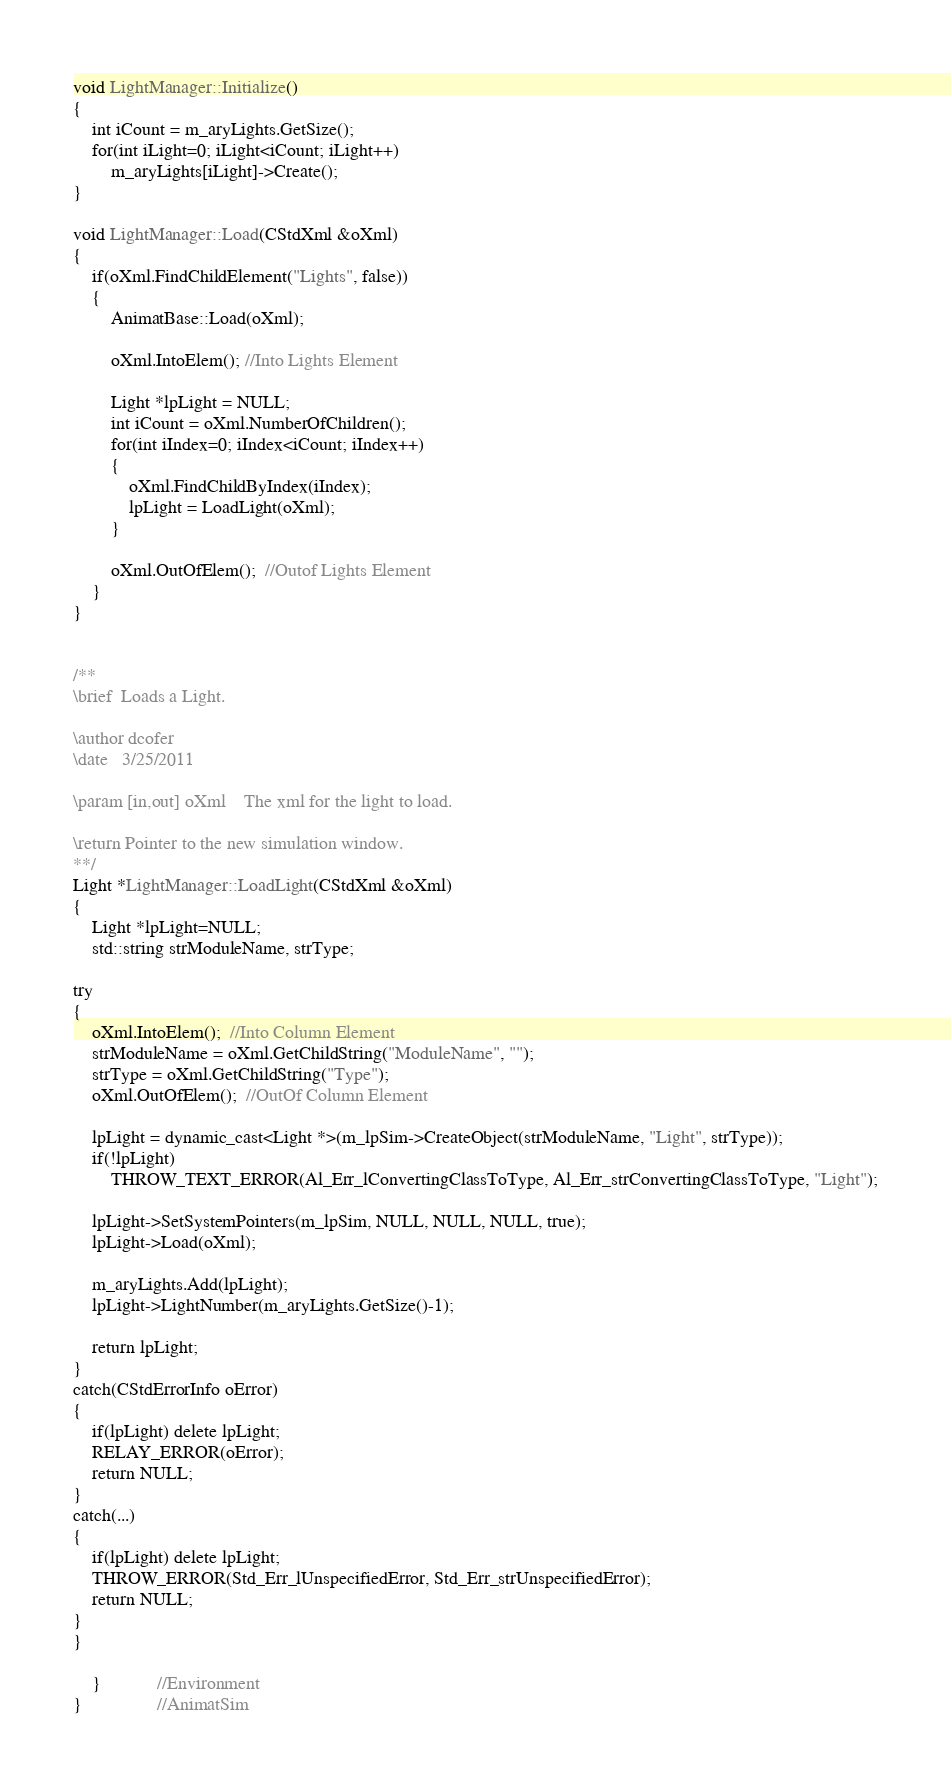Convert code to text. <code><loc_0><loc_0><loc_500><loc_500><_C++_>void LightManager::Initialize()
{
	int iCount = m_aryLights.GetSize();
	for(int iLight=0; iLight<iCount; iLight++)
		m_aryLights[iLight]->Create();
}

void LightManager::Load(CStdXml &oXml)
{
	if(oXml.FindChildElement("Lights", false))
	{
		AnimatBase::Load(oXml);
	
		oXml.IntoElem(); //Into Lights Element

		Light *lpLight = NULL;
		int iCount = oXml.NumberOfChildren();
		for(int iIndex=0; iIndex<iCount; iIndex++)
		{
			oXml.FindChildByIndex(iIndex);
			lpLight = LoadLight(oXml);
		}

		oXml.OutOfElem();  //Outof Lights Element
	}
}


/**
\brief	Loads a Light.

\author	dcofer
\date	3/25/2011

\param [in,out]	oXml	The xml for the light to load. 

\return	Pointer to the new simulation window.
**/
Light *LightManager::LoadLight(CStdXml &oXml)
{
	Light *lpLight=NULL;
	std::string strModuleName, strType;

try
{
	oXml.IntoElem();  //Into Column Element
	strModuleName = oXml.GetChildString("ModuleName", "");
	strType = oXml.GetChildString("Type");
	oXml.OutOfElem();  //OutOf Column Element

	lpLight = dynamic_cast<Light *>(m_lpSim->CreateObject(strModuleName, "Light", strType));
	if(!lpLight)
		THROW_TEXT_ERROR(Al_Err_lConvertingClassToType, Al_Err_strConvertingClassToType, "Light");

	lpLight->SetSystemPointers(m_lpSim, NULL, NULL, NULL, true);
	lpLight->Load(oXml);

	m_aryLights.Add(lpLight);
    lpLight->LightNumber(m_aryLights.GetSize()-1);

	return lpLight;
}
catch(CStdErrorInfo oError)
{
	if(lpLight) delete lpLight;
	RELAY_ERROR(oError);
	return NULL;
}
catch(...)
{
	if(lpLight) delete lpLight;
	THROW_ERROR(Std_Err_lUnspecifiedError, Std_Err_strUnspecifiedError);
	return NULL;
}
}

	}			//Environment
}				//AnimatSim</code> 